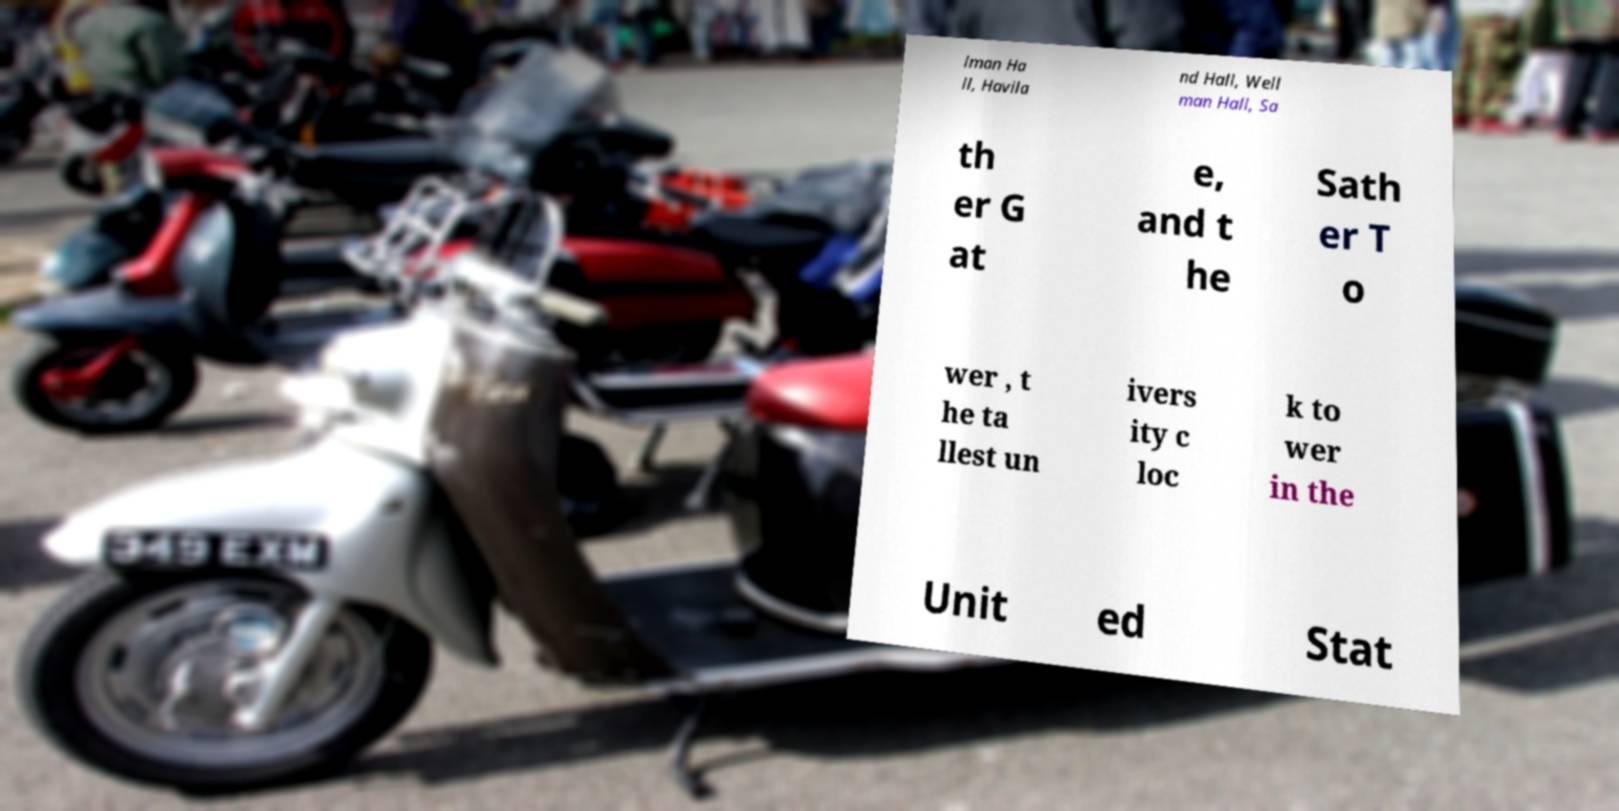Can you accurately transcribe the text from the provided image for me? lman Ha ll, Havila nd Hall, Well man Hall, Sa th er G at e, and t he Sath er T o wer , t he ta llest un ivers ity c loc k to wer in the Unit ed Stat 